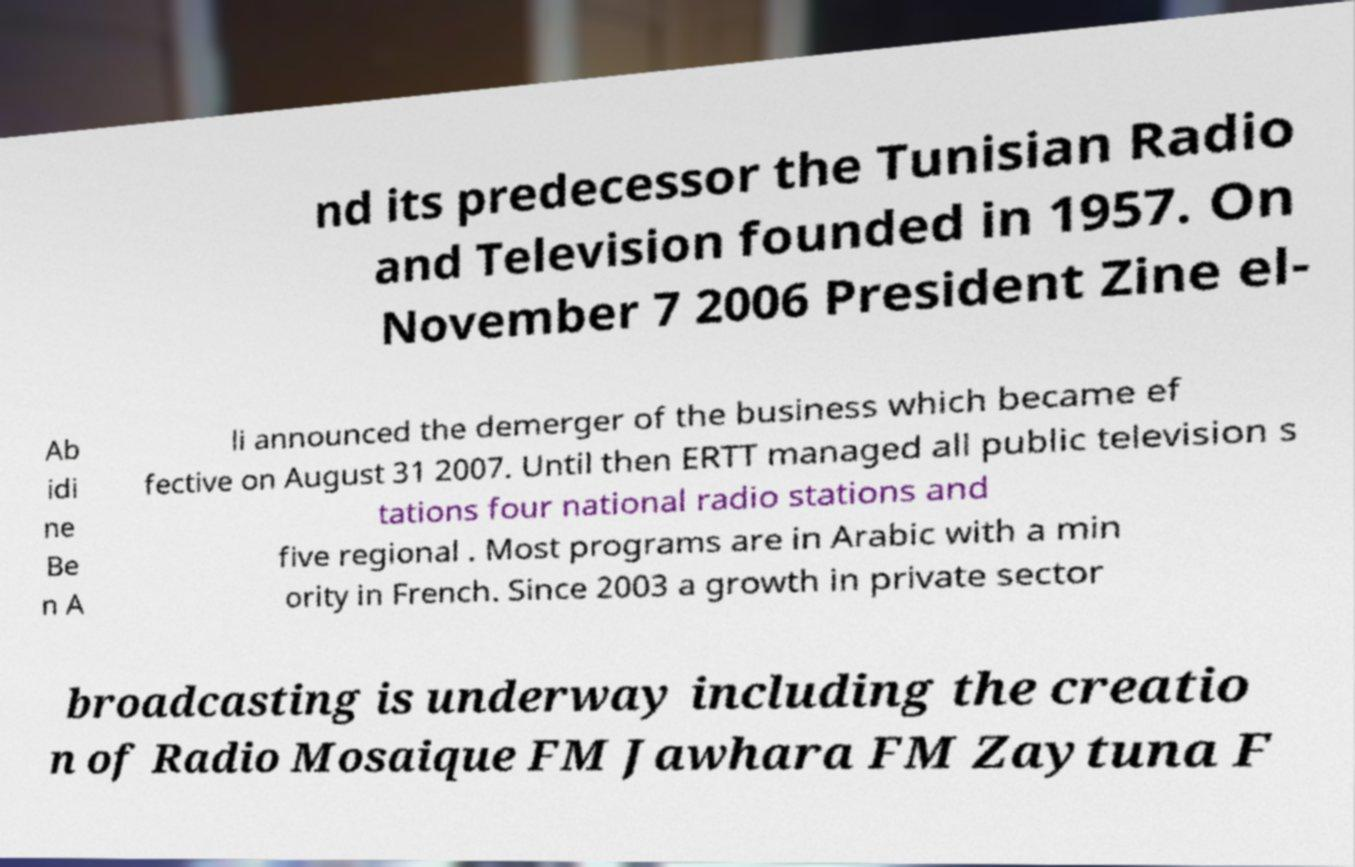There's text embedded in this image that I need extracted. Can you transcribe it verbatim? nd its predecessor the Tunisian Radio and Television founded in 1957. On November 7 2006 President Zine el- Ab idi ne Be n A li announced the demerger of the business which became ef fective on August 31 2007. Until then ERTT managed all public television s tations four national radio stations and five regional . Most programs are in Arabic with a min ority in French. Since 2003 a growth in private sector broadcasting is underway including the creatio n of Radio Mosaique FM Jawhara FM Zaytuna F 